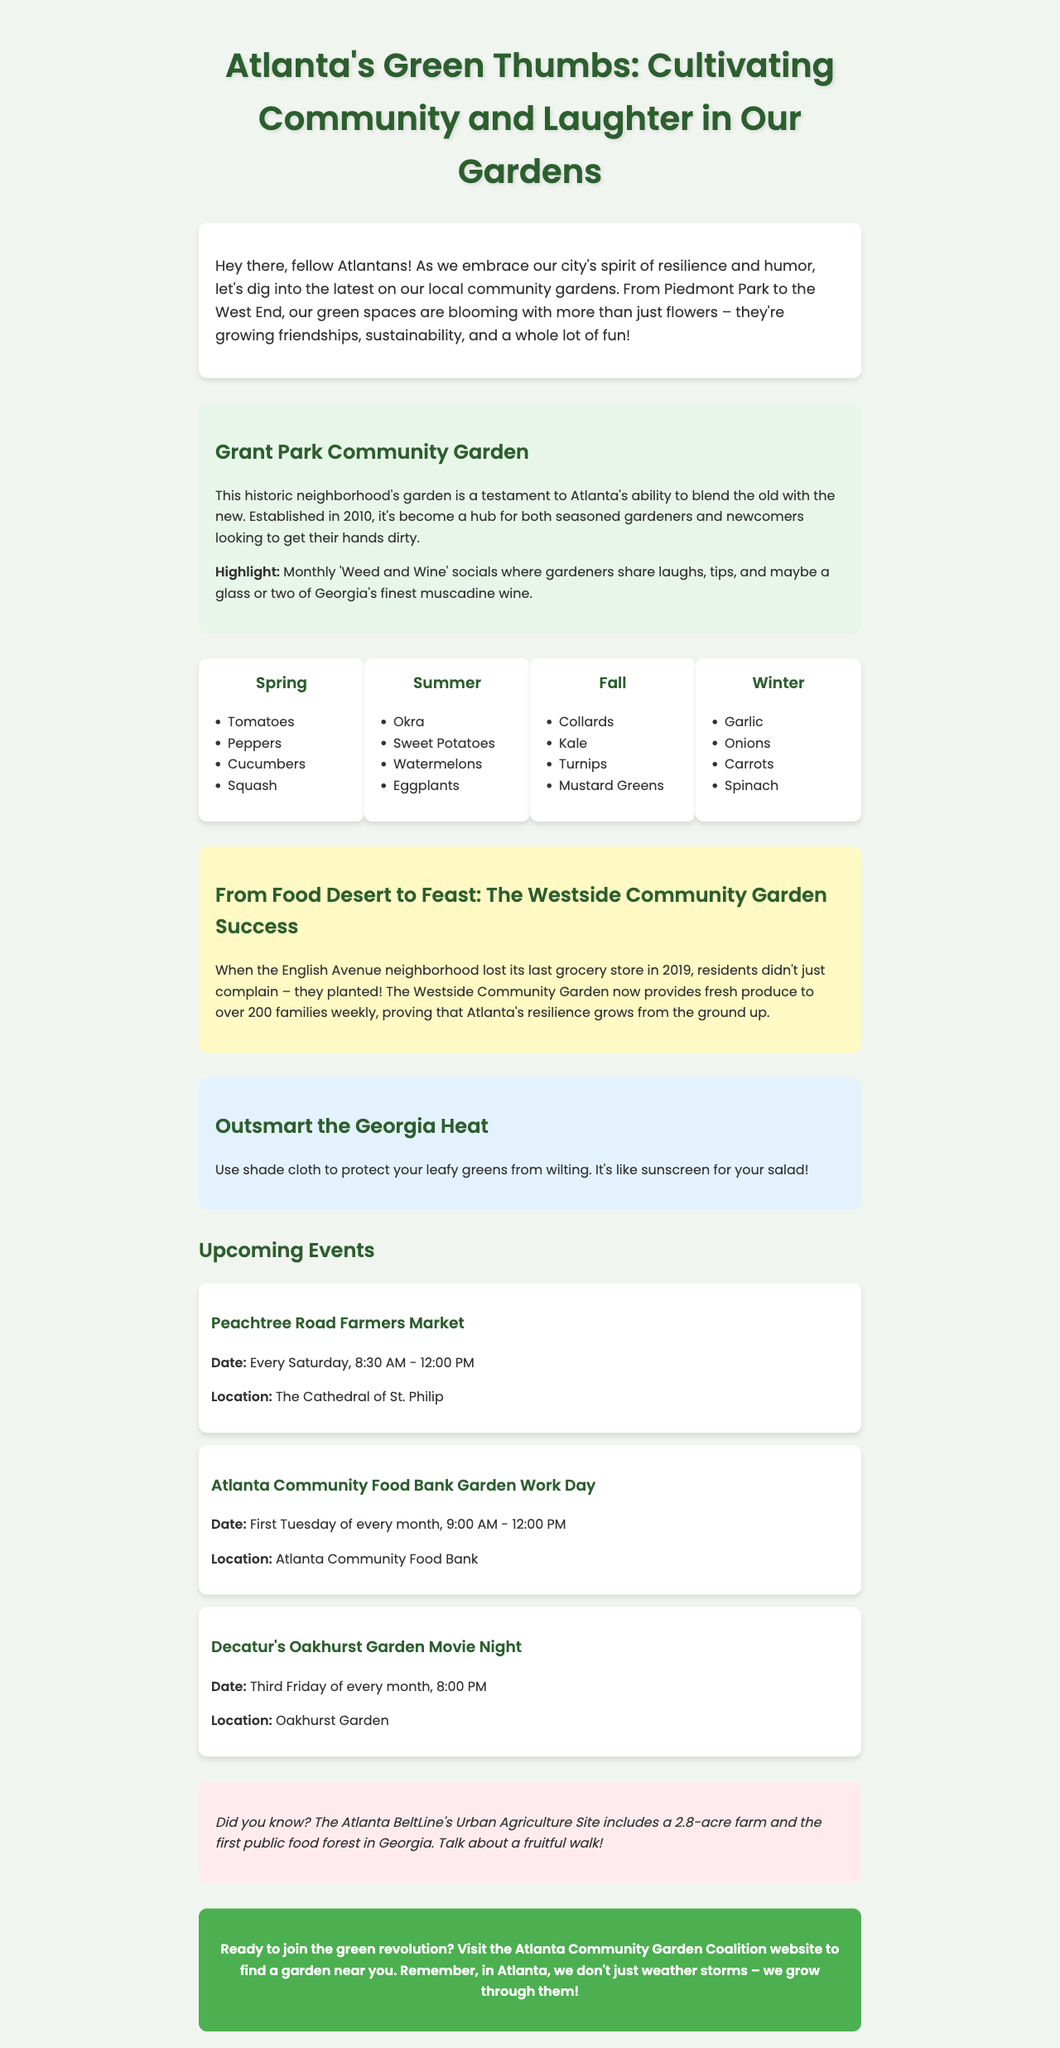What is the title of the newsletter? The title of the newsletter is found at the top of the document.
Answer: Atlanta's Green Thumbs: Cultivating Community and Laughter in Our Gardens What is the featured garden's name? The name of the featured garden is stated directly in the document.
Answer: Grant Park Community Garden What is the highlight of the Grant Park Community Garden? The highlight describes a specific activity that stands out in this garden’s community.
Answer: Monthly 'Weed and Wine' socials Which vegetables are recommended for summer planting? The section on seasonal plantings lists specific vegetables for each season.
Answer: Okra, Sweet Potatoes, Watermelons, Eggplants How many families does the Westside Community Garden serve weekly? The community impact story mentions the number of families benefiting from the garden.
Answer: Over 200 families What gardening tip is provided for dealing with the Georgia heat? The document includes a specific tip aimed at managing gardening conditions in Georgia.
Answer: Use shade cloth When does the Peachtree Road Farmers Market take place? The event details specify the recurring schedule for this farmers market.
Answer: Every Saturday, 8:30 AM - 12:00 PM What unique feature can be found at the Atlanta BeltLine's Urban Agriculture Site? The fun fact highlights a specific unique characteristic of this site.
Answer: The first public food forest in Georgia What month does the Atlanta Community Food Bank Garden Work Day occur? The upcoming events provide the specific timing for this event each month.
Answer: First Tuesday of every month 